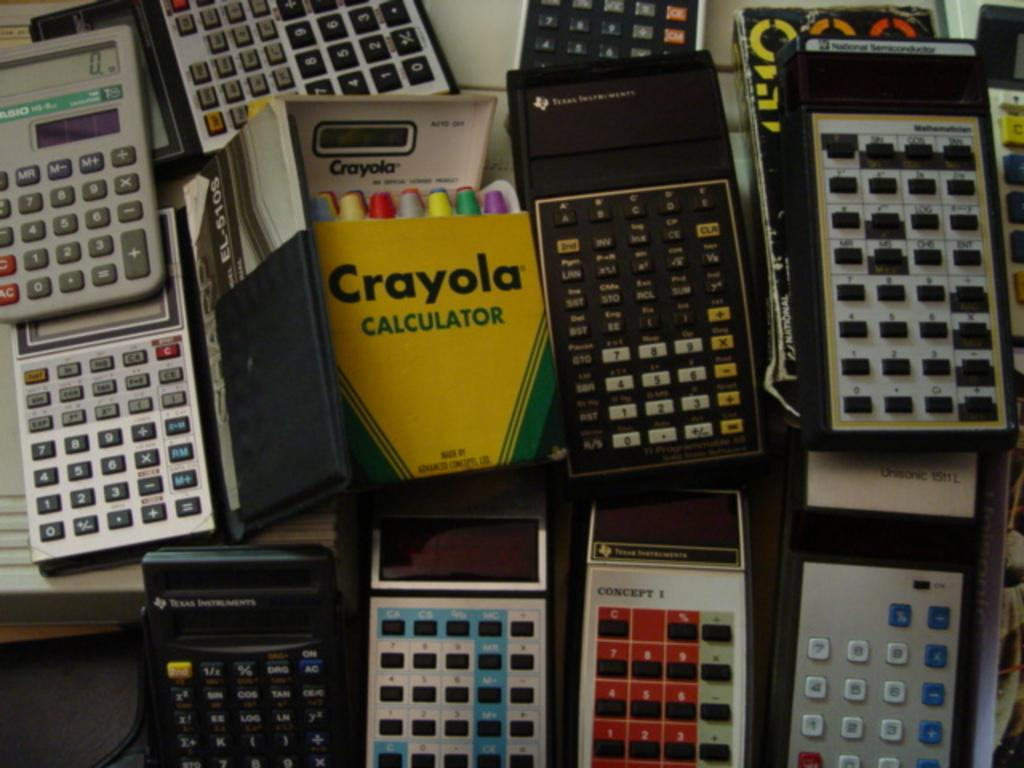<image>
Write a terse but informative summary of the picture. A crayola calculator among other types of calculators 